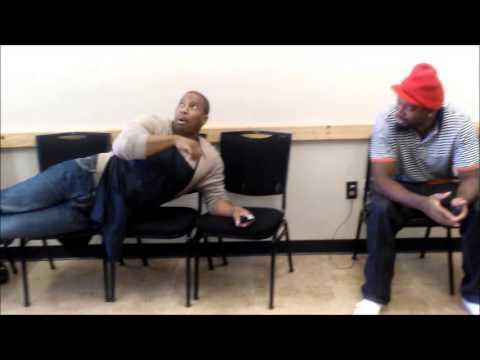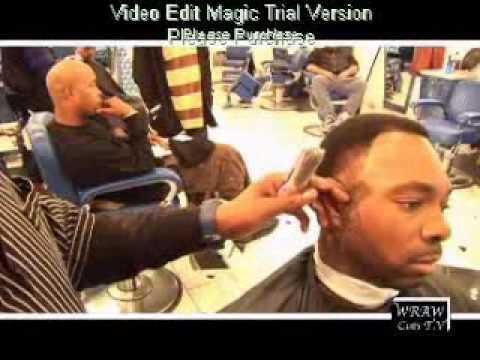The first image is the image on the left, the second image is the image on the right. For the images shown, is this caption "You can see there is a TV hanging on the wall in at least one of the images." true? Answer yes or no. No. 